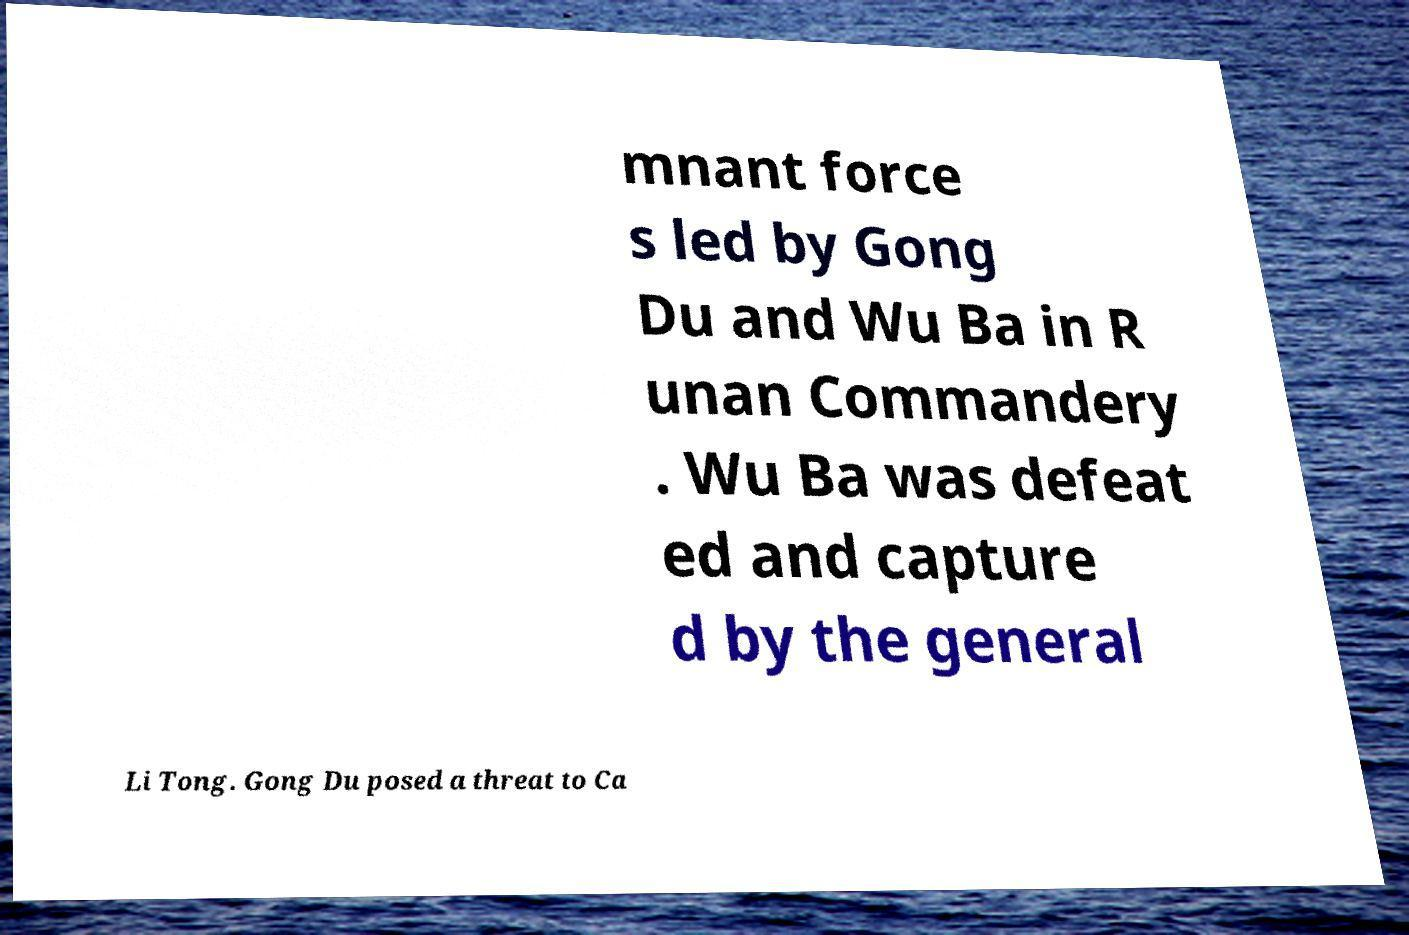Can you accurately transcribe the text from the provided image for me? mnant force s led by Gong Du and Wu Ba in R unan Commandery . Wu Ba was defeat ed and capture d by the general Li Tong. Gong Du posed a threat to Ca 